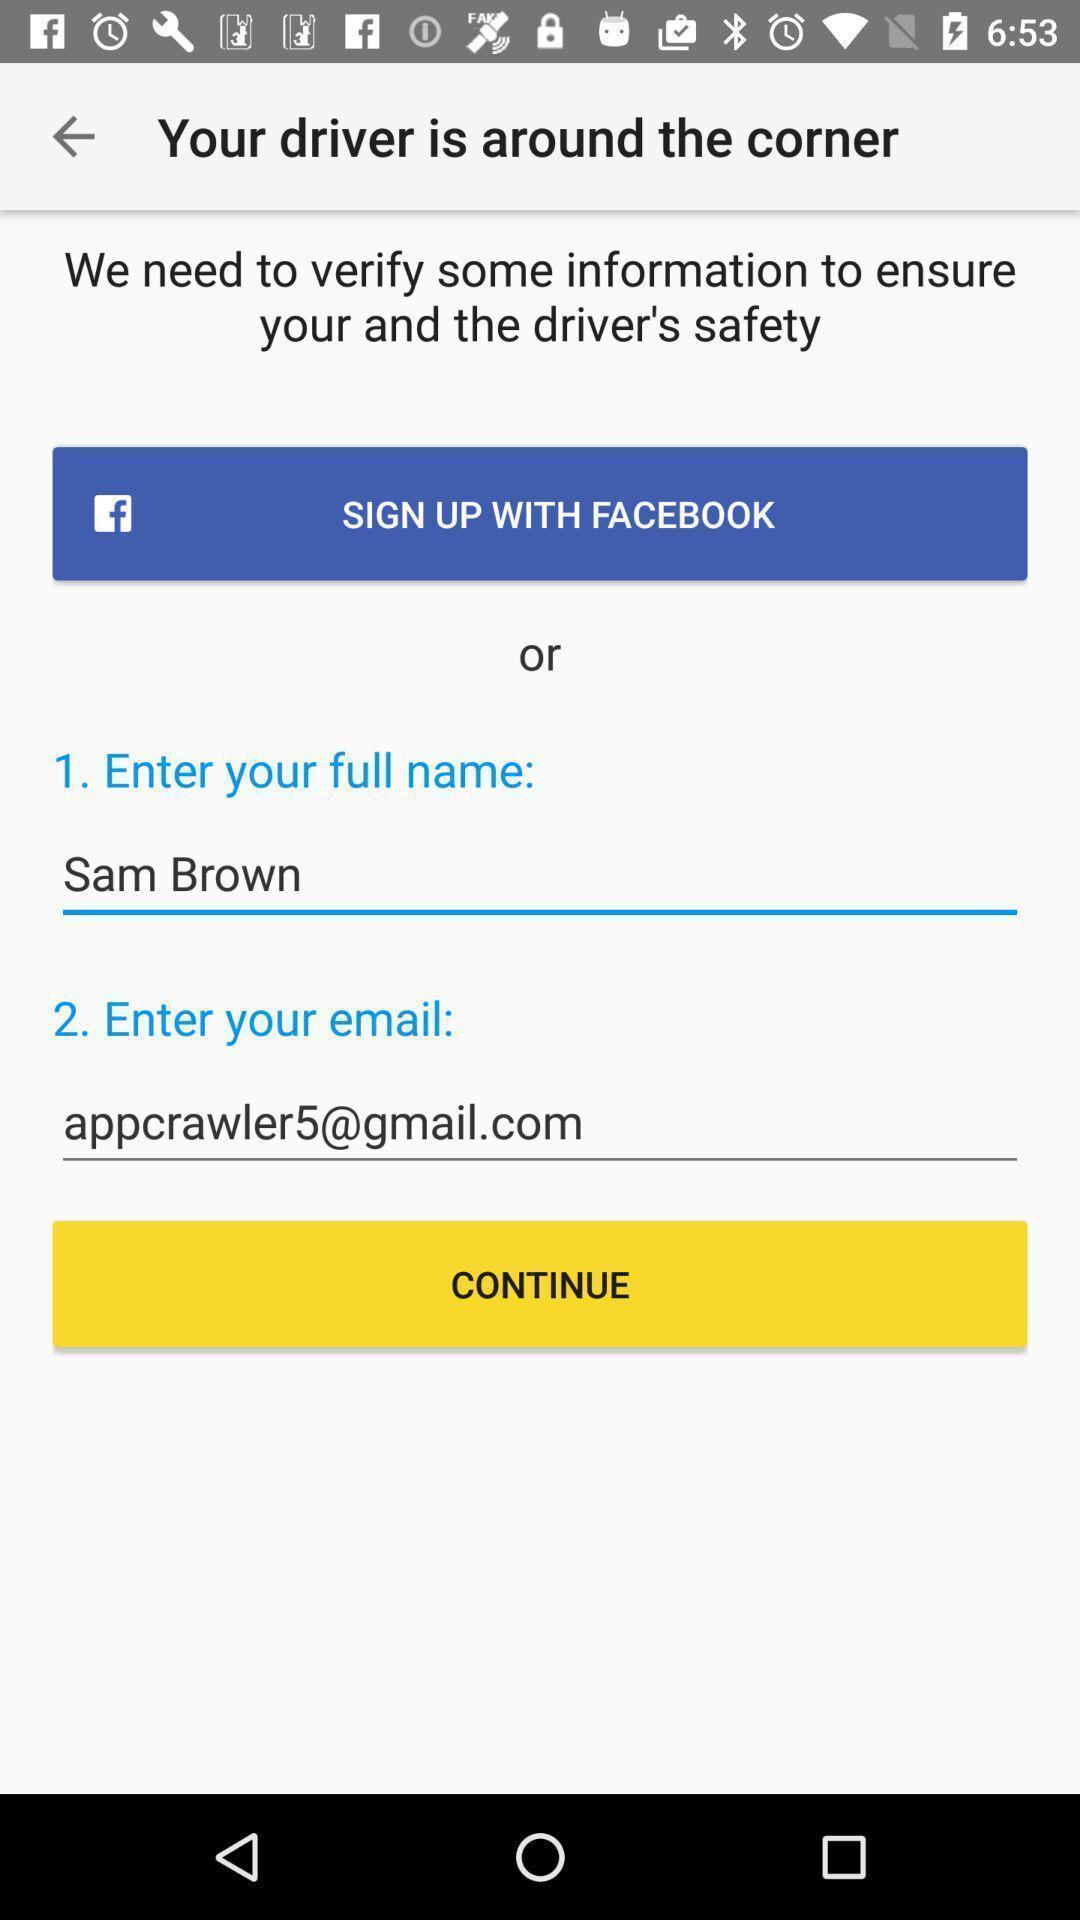What can you discern from this picture? Verify some information in driver is around corner. 